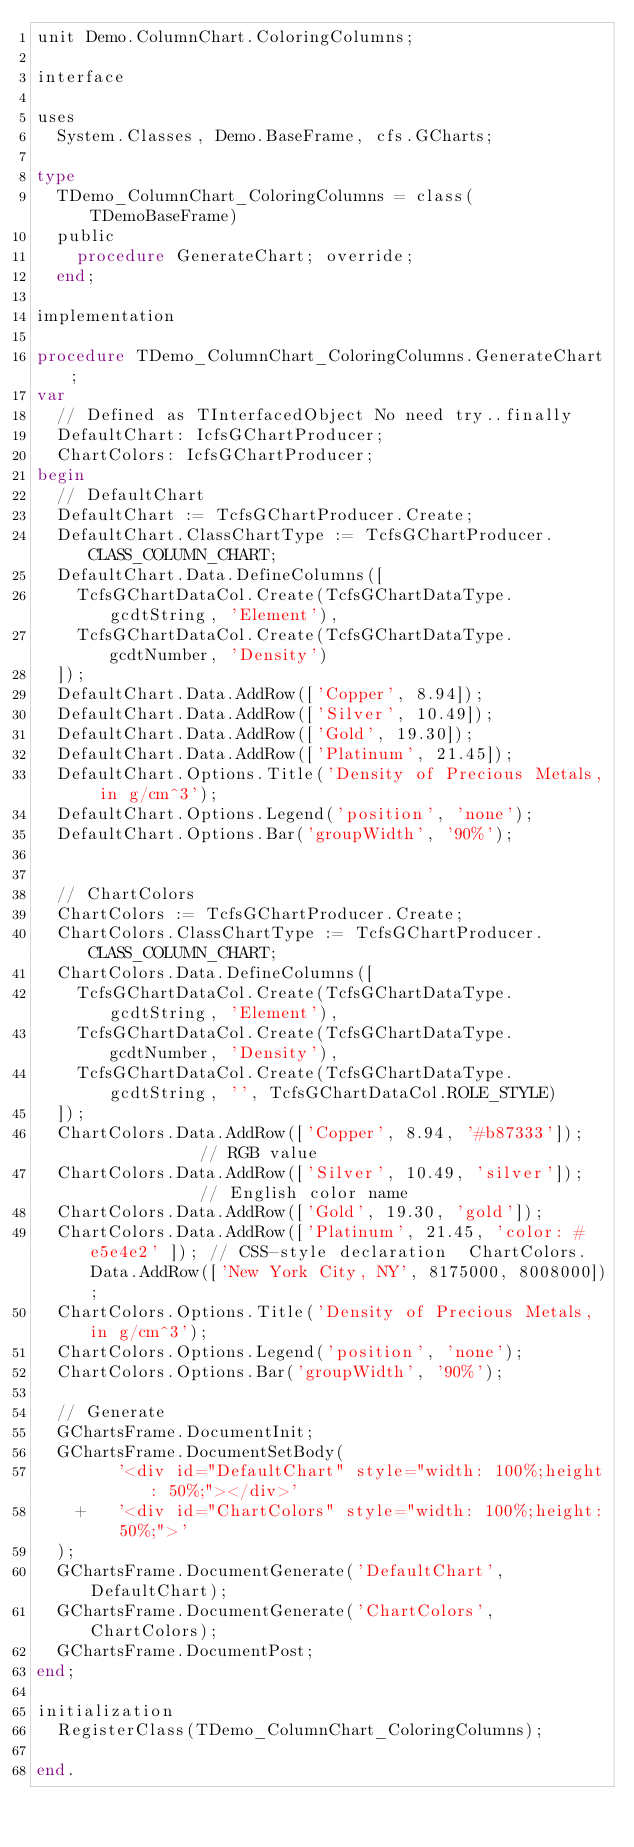Convert code to text. <code><loc_0><loc_0><loc_500><loc_500><_Pascal_>unit Demo.ColumnChart.ColoringColumns;

interface

uses
  System.Classes, Demo.BaseFrame, cfs.GCharts;

type
  TDemo_ColumnChart_ColoringColumns = class(TDemoBaseFrame)
  public
    procedure GenerateChart; override;
  end;

implementation

procedure TDemo_ColumnChart_ColoringColumns.GenerateChart;
var
  // Defined as TInterfacedObject No need try..finally
  DefaultChart: IcfsGChartProducer;
  ChartColors: IcfsGChartProducer;
begin
  // DefaultChart
  DefaultChart := TcfsGChartProducer.Create;
  DefaultChart.ClassChartType := TcfsGChartProducer.CLASS_COLUMN_CHART;
  DefaultChart.Data.DefineColumns([
    TcfsGChartDataCol.Create(TcfsGChartDataType.gcdtString, 'Element'),
    TcfsGChartDataCol.Create(TcfsGChartDataType.gcdtNumber, 'Density')
  ]);
  DefaultChart.Data.AddRow(['Copper', 8.94]);
  DefaultChart.Data.AddRow(['Silver', 10.49]);
  DefaultChart.Data.AddRow(['Gold', 19.30]);
  DefaultChart.Data.AddRow(['Platinum', 21.45]);
  DefaultChart.Options.Title('Density of Precious Metals, in g/cm^3');
  DefaultChart.Options.Legend('position', 'none');
  DefaultChart.Options.Bar('groupWidth', '90%');


  // ChartColors
  ChartColors := TcfsGChartProducer.Create;
  ChartColors.ClassChartType := TcfsGChartProducer.CLASS_COLUMN_CHART;
  ChartColors.Data.DefineColumns([
    TcfsGChartDataCol.Create(TcfsGChartDataType.gcdtString, 'Element'),
    TcfsGChartDataCol.Create(TcfsGChartDataType.gcdtNumber, 'Density'),
    TcfsGChartDataCol.Create(TcfsGChartDataType.gcdtString, '', TcfsGChartDataCol.ROLE_STYLE)
  ]);
  ChartColors.Data.AddRow(['Copper', 8.94, '#b87333']);            // RGB value
  ChartColors.Data.AddRow(['Silver', 10.49, 'silver']);            // English color name
  ChartColors.Data.AddRow(['Gold', 19.30, 'gold']);
  ChartColors.Data.AddRow(['Platinum', 21.45, 'color: #e5e4e2' ]); // CSS-style declaration  ChartColors.Data.AddRow(['New York City, NY', 8175000, 8008000]);
  ChartColors.Options.Title('Density of Precious Metals, in g/cm^3');
  ChartColors.Options.Legend('position', 'none');
  ChartColors.Options.Bar('groupWidth', '90%');

  // Generate
  GChartsFrame.DocumentInit;
  GChartsFrame.DocumentSetBody(
        '<div id="DefaultChart" style="width: 100%;height: 50%;"></div>'
    +   '<div id="ChartColors" style="width: 100%;height: 50%;">'
  );
  GChartsFrame.DocumentGenerate('DefaultChart', DefaultChart);
  GChartsFrame.DocumentGenerate('ChartColors', ChartColors);
  GChartsFrame.DocumentPost;
end;

initialization
  RegisterClass(TDemo_ColumnChart_ColoringColumns);

end.

</code> 